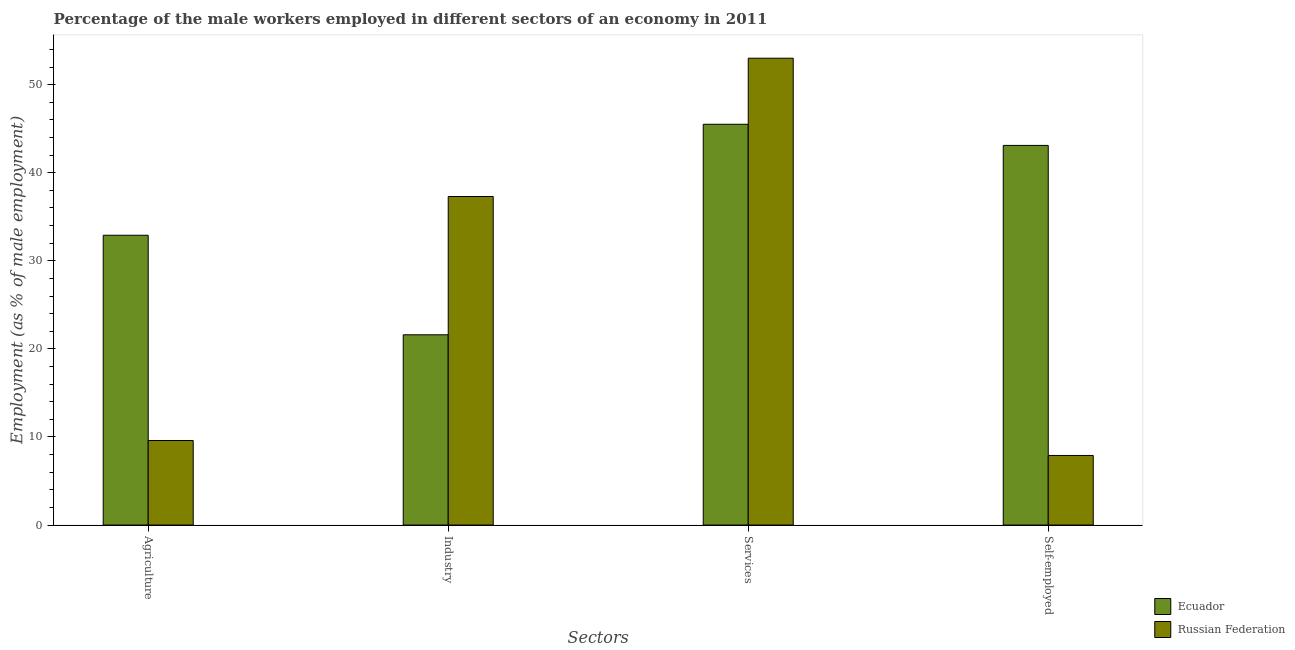How many different coloured bars are there?
Keep it short and to the point. 2. Are the number of bars on each tick of the X-axis equal?
Your response must be concise. Yes. How many bars are there on the 3rd tick from the left?
Offer a very short reply. 2. What is the label of the 2nd group of bars from the left?
Make the answer very short. Industry. What is the percentage of male workers in industry in Ecuador?
Your answer should be very brief. 21.6. Across all countries, what is the maximum percentage of male workers in industry?
Keep it short and to the point. 37.3. Across all countries, what is the minimum percentage of male workers in services?
Your answer should be compact. 45.5. In which country was the percentage of male workers in services maximum?
Give a very brief answer. Russian Federation. In which country was the percentage of male workers in agriculture minimum?
Provide a short and direct response. Russian Federation. What is the total percentage of male workers in industry in the graph?
Your response must be concise. 58.9. What is the difference between the percentage of male workers in industry in Ecuador and that in Russian Federation?
Keep it short and to the point. -15.7. What is the difference between the percentage of male workers in agriculture in Ecuador and the percentage of self employed male workers in Russian Federation?
Provide a short and direct response. 25. What is the average percentage of male workers in services per country?
Keep it short and to the point. 49.25. What is the difference between the percentage of self employed male workers and percentage of male workers in agriculture in Ecuador?
Your response must be concise. 10.2. What is the ratio of the percentage of self employed male workers in Ecuador to that in Russian Federation?
Offer a very short reply. 5.46. Is the percentage of self employed male workers in Russian Federation less than that in Ecuador?
Offer a very short reply. Yes. What is the difference between the highest and the second highest percentage of male workers in industry?
Offer a very short reply. 15.7. Is the sum of the percentage of self employed male workers in Russian Federation and Ecuador greater than the maximum percentage of male workers in industry across all countries?
Provide a succinct answer. Yes. Is it the case that in every country, the sum of the percentage of self employed male workers and percentage of male workers in agriculture is greater than the sum of percentage of male workers in industry and percentage of male workers in services?
Keep it short and to the point. No. What does the 1st bar from the left in Industry represents?
Provide a short and direct response. Ecuador. What does the 2nd bar from the right in Services represents?
Your answer should be compact. Ecuador. Is it the case that in every country, the sum of the percentage of male workers in agriculture and percentage of male workers in industry is greater than the percentage of male workers in services?
Provide a short and direct response. No. How many bars are there?
Provide a succinct answer. 8. Are all the bars in the graph horizontal?
Your answer should be compact. No. How many countries are there in the graph?
Provide a short and direct response. 2. Are the values on the major ticks of Y-axis written in scientific E-notation?
Your answer should be compact. No. Does the graph contain grids?
Give a very brief answer. No. How many legend labels are there?
Keep it short and to the point. 2. How are the legend labels stacked?
Your answer should be compact. Vertical. What is the title of the graph?
Provide a short and direct response. Percentage of the male workers employed in different sectors of an economy in 2011. What is the label or title of the X-axis?
Your answer should be compact. Sectors. What is the label or title of the Y-axis?
Give a very brief answer. Employment (as % of male employment). What is the Employment (as % of male employment) in Ecuador in Agriculture?
Provide a short and direct response. 32.9. What is the Employment (as % of male employment) of Russian Federation in Agriculture?
Offer a terse response. 9.6. What is the Employment (as % of male employment) of Ecuador in Industry?
Your response must be concise. 21.6. What is the Employment (as % of male employment) of Russian Federation in Industry?
Your answer should be compact. 37.3. What is the Employment (as % of male employment) in Ecuador in Services?
Your answer should be compact. 45.5. What is the Employment (as % of male employment) in Russian Federation in Services?
Keep it short and to the point. 53. What is the Employment (as % of male employment) in Ecuador in Self-employed?
Make the answer very short. 43.1. What is the Employment (as % of male employment) of Russian Federation in Self-employed?
Your answer should be compact. 7.9. Across all Sectors, what is the maximum Employment (as % of male employment) of Ecuador?
Your answer should be very brief. 45.5. Across all Sectors, what is the minimum Employment (as % of male employment) in Ecuador?
Your response must be concise. 21.6. Across all Sectors, what is the minimum Employment (as % of male employment) of Russian Federation?
Keep it short and to the point. 7.9. What is the total Employment (as % of male employment) of Ecuador in the graph?
Provide a short and direct response. 143.1. What is the total Employment (as % of male employment) in Russian Federation in the graph?
Ensure brevity in your answer.  107.8. What is the difference between the Employment (as % of male employment) in Russian Federation in Agriculture and that in Industry?
Give a very brief answer. -27.7. What is the difference between the Employment (as % of male employment) of Russian Federation in Agriculture and that in Services?
Your answer should be very brief. -43.4. What is the difference between the Employment (as % of male employment) of Ecuador in Agriculture and that in Self-employed?
Provide a succinct answer. -10.2. What is the difference between the Employment (as % of male employment) in Ecuador in Industry and that in Services?
Give a very brief answer. -23.9. What is the difference between the Employment (as % of male employment) in Russian Federation in Industry and that in Services?
Provide a short and direct response. -15.7. What is the difference between the Employment (as % of male employment) of Ecuador in Industry and that in Self-employed?
Offer a terse response. -21.5. What is the difference between the Employment (as % of male employment) of Russian Federation in Industry and that in Self-employed?
Ensure brevity in your answer.  29.4. What is the difference between the Employment (as % of male employment) in Russian Federation in Services and that in Self-employed?
Offer a very short reply. 45.1. What is the difference between the Employment (as % of male employment) of Ecuador in Agriculture and the Employment (as % of male employment) of Russian Federation in Industry?
Keep it short and to the point. -4.4. What is the difference between the Employment (as % of male employment) of Ecuador in Agriculture and the Employment (as % of male employment) of Russian Federation in Services?
Offer a terse response. -20.1. What is the difference between the Employment (as % of male employment) in Ecuador in Agriculture and the Employment (as % of male employment) in Russian Federation in Self-employed?
Keep it short and to the point. 25. What is the difference between the Employment (as % of male employment) of Ecuador in Industry and the Employment (as % of male employment) of Russian Federation in Services?
Your answer should be compact. -31.4. What is the difference between the Employment (as % of male employment) in Ecuador in Services and the Employment (as % of male employment) in Russian Federation in Self-employed?
Provide a succinct answer. 37.6. What is the average Employment (as % of male employment) in Ecuador per Sectors?
Offer a terse response. 35.77. What is the average Employment (as % of male employment) of Russian Federation per Sectors?
Offer a terse response. 26.95. What is the difference between the Employment (as % of male employment) of Ecuador and Employment (as % of male employment) of Russian Federation in Agriculture?
Make the answer very short. 23.3. What is the difference between the Employment (as % of male employment) of Ecuador and Employment (as % of male employment) of Russian Federation in Industry?
Offer a terse response. -15.7. What is the difference between the Employment (as % of male employment) of Ecuador and Employment (as % of male employment) of Russian Federation in Services?
Provide a short and direct response. -7.5. What is the difference between the Employment (as % of male employment) in Ecuador and Employment (as % of male employment) in Russian Federation in Self-employed?
Provide a short and direct response. 35.2. What is the ratio of the Employment (as % of male employment) of Ecuador in Agriculture to that in Industry?
Provide a succinct answer. 1.52. What is the ratio of the Employment (as % of male employment) in Russian Federation in Agriculture to that in Industry?
Make the answer very short. 0.26. What is the ratio of the Employment (as % of male employment) of Ecuador in Agriculture to that in Services?
Provide a succinct answer. 0.72. What is the ratio of the Employment (as % of male employment) of Russian Federation in Agriculture to that in Services?
Provide a short and direct response. 0.18. What is the ratio of the Employment (as % of male employment) in Ecuador in Agriculture to that in Self-employed?
Your answer should be very brief. 0.76. What is the ratio of the Employment (as % of male employment) in Russian Federation in Agriculture to that in Self-employed?
Keep it short and to the point. 1.22. What is the ratio of the Employment (as % of male employment) in Ecuador in Industry to that in Services?
Give a very brief answer. 0.47. What is the ratio of the Employment (as % of male employment) in Russian Federation in Industry to that in Services?
Provide a short and direct response. 0.7. What is the ratio of the Employment (as % of male employment) in Ecuador in Industry to that in Self-employed?
Offer a very short reply. 0.5. What is the ratio of the Employment (as % of male employment) in Russian Federation in Industry to that in Self-employed?
Provide a succinct answer. 4.72. What is the ratio of the Employment (as % of male employment) in Ecuador in Services to that in Self-employed?
Make the answer very short. 1.06. What is the ratio of the Employment (as % of male employment) in Russian Federation in Services to that in Self-employed?
Provide a succinct answer. 6.71. What is the difference between the highest and the second highest Employment (as % of male employment) in Ecuador?
Your response must be concise. 2.4. What is the difference between the highest and the second highest Employment (as % of male employment) of Russian Federation?
Your response must be concise. 15.7. What is the difference between the highest and the lowest Employment (as % of male employment) of Ecuador?
Keep it short and to the point. 23.9. What is the difference between the highest and the lowest Employment (as % of male employment) in Russian Federation?
Offer a terse response. 45.1. 